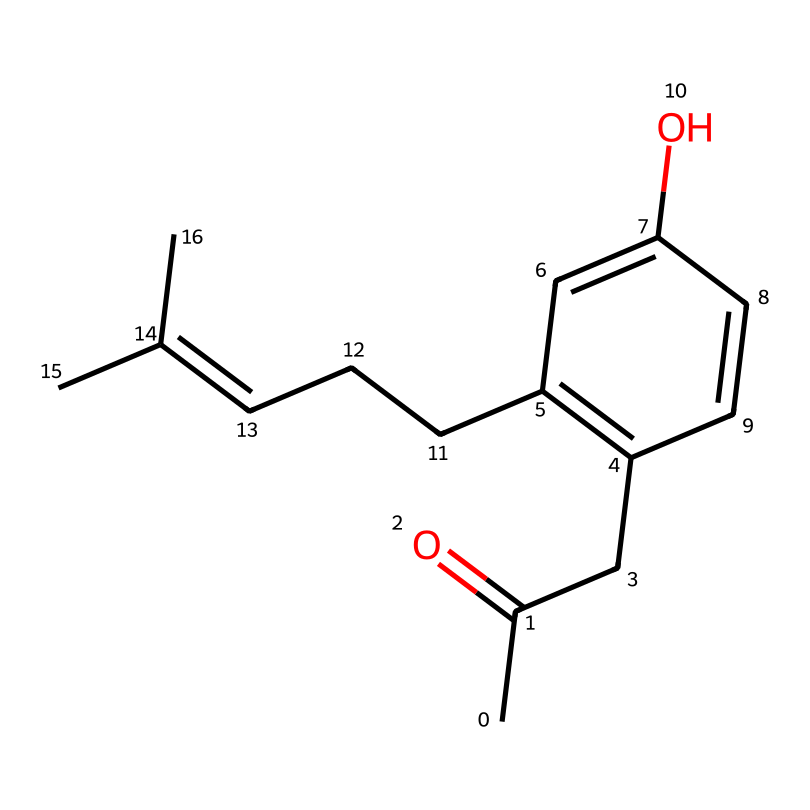What is the molecular formula of raspberry ketone? By analyzing the SMILES representation, we can count the number of carbon (C), hydrogen (H), and oxygen (O) atoms. The structure indicates there are 10 carbon atoms, 12 hydrogen atoms, and 1 oxygen atom. Therefore, the molecular formula is C10H12O.
Answer: C10H12O How many rings are present in the structure of raspberry ketone? In the SMILES representation, there is a section indicating cyclic structures, specifically through the usage of 'C=C' bonds that create a ring. This chemical contains one cyclic structure present in the double bond format.
Answer: 1 What functional group is characteristic of ketones which raspberry ketone possesses? Ketones are defined by the presence of a carbonyl group (C=O). In the given SMILES, the presence of 'C=O' indicates that this compound contains a ketone functional group.
Answer: carbonyl group What is the significance of the hydroxyl group in raspberry ketone? The presence of a hydroxyl group (-OH) in the structure indicates that raspberry ketone may have some potential antioxidant properties, enhancing its health benefits. This is because the -OH group can act as a donating entity to quench free radicals.
Answer: antioxidant properties How many double bonds are present in raspberry ketone? By examining the SMILES representation, double bonds are indicated by the '=' signs. Counting these, we find there are 4 double bonds in total throughout the structure of the chemical.
Answer: 4 Which part of raspberry ketone's structure indicates its aromatic character? Aromatic character in a chemical structure is often indicated by conjugated double bonds within a cyclic arrangement. The alternating double bonds in the cyclic portion visible in the SMILES indicate that this compound has an aromatic ring.
Answer: cyclic portion with alternating double bonds 